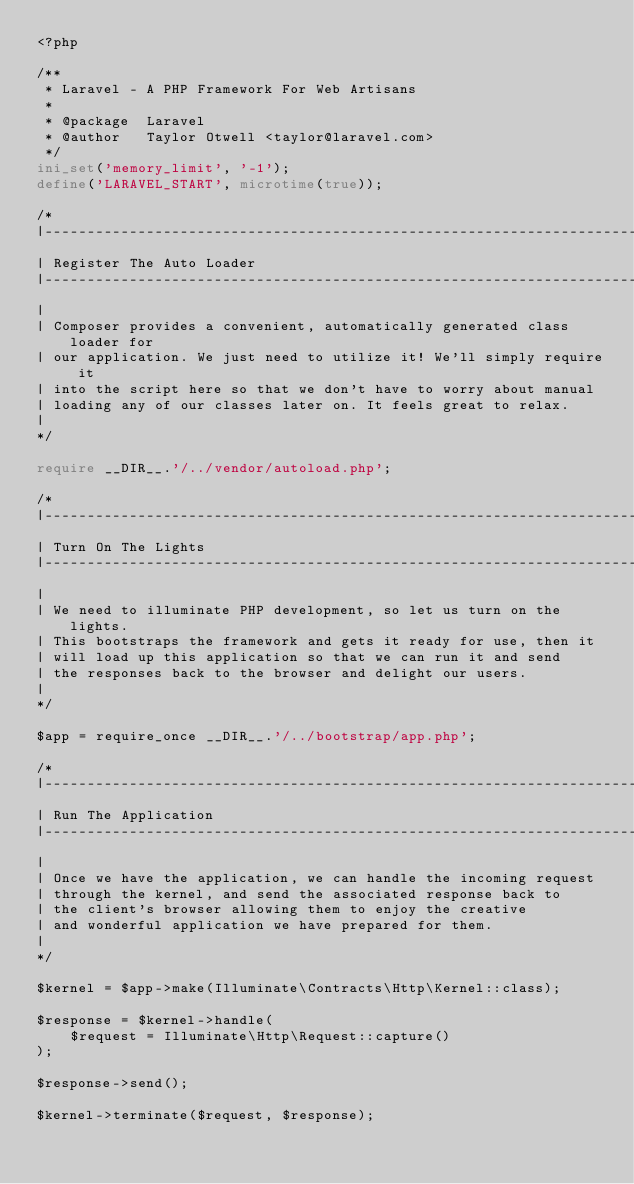Convert code to text. <code><loc_0><loc_0><loc_500><loc_500><_PHP_><?php

/**
 * Laravel - A PHP Framework For Web Artisans
 *
 * @package  Laravel
 * @author   Taylor Otwell <taylor@laravel.com>
 */
ini_set('memory_limit', '-1');
define('LARAVEL_START', microtime(true));

/*
|--------------------------------------------------------------------------
| Register The Auto Loader
|--------------------------------------------------------------------------
|
| Composer provides a convenient, automatically generated class loader for
| our application. We just need to utilize it! We'll simply require it
| into the script here so that we don't have to worry about manual
| loading any of our classes later on. It feels great to relax.
|
*/

require __DIR__.'/../vendor/autoload.php';

/*
|--------------------------------------------------------------------------
| Turn On The Lights
|--------------------------------------------------------------------------
|
| We need to illuminate PHP development, so let us turn on the lights.
| This bootstraps the framework and gets it ready for use, then it
| will load up this application so that we can run it and send
| the responses back to the browser and delight our users.
|
*/

$app = require_once __DIR__.'/../bootstrap/app.php';

/*
|--------------------------------------------------------------------------
| Run The Application
|--------------------------------------------------------------------------
|
| Once we have the application, we can handle the incoming request
| through the kernel, and send the associated response back to
| the client's browser allowing them to enjoy the creative
| and wonderful application we have prepared for them.
|
*/

$kernel = $app->make(Illuminate\Contracts\Http\Kernel::class);

$response = $kernel->handle(
    $request = Illuminate\Http\Request::capture()
);

$response->send();

$kernel->terminate($request, $response);

</code> 